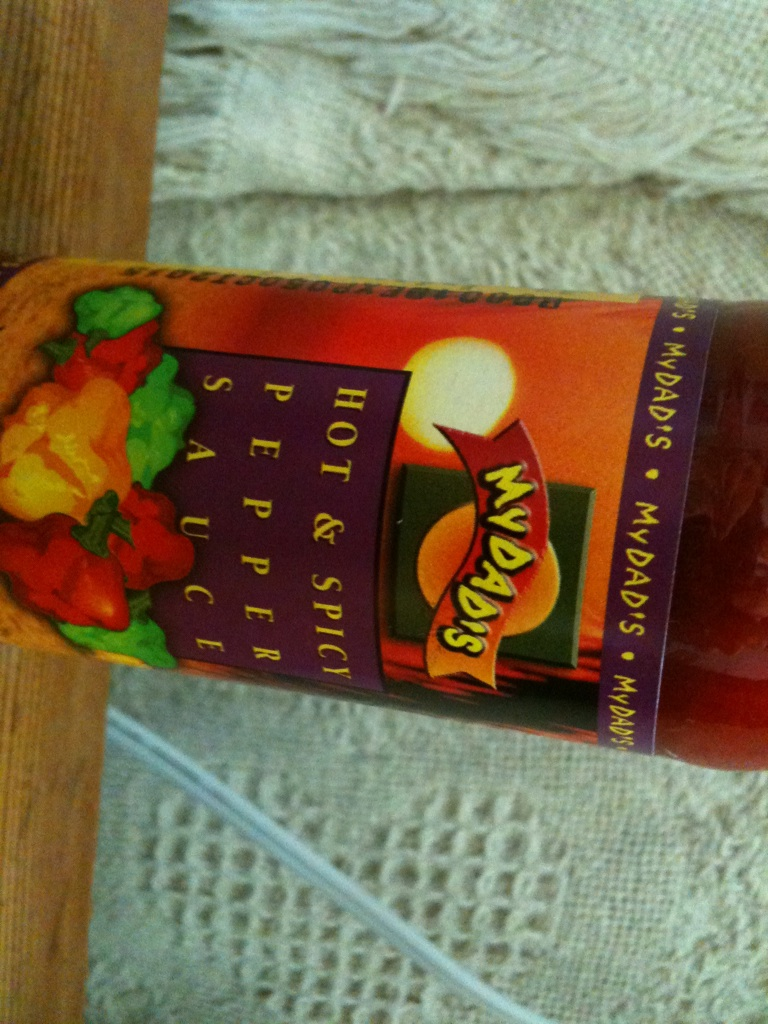Can you think of an imaginative scenario involving this pepper sauce? Imagine a culinary competition where chefs from around the world converge in a mystical forest to create the ultimate spicy dish. The secret ingredient? This very bottle of 'MYDAD'S Hot & Spicy Pepper Sauce'. Each chef must incorporate the sauce into a dish that not only tantalizes the taste buds but also tells a story. One chef decides to create a dish inspired by a dragon’s fiery breath, with seared dragonfruit slices glazed with the pepper sauce, accompanied by spice-infused, roasted meats, and served with a side of enchanted forest greens. The heat from the sauce symbolizes the dragon's flames, while the unique presentation and flavors capture the imaginations of the judges. 